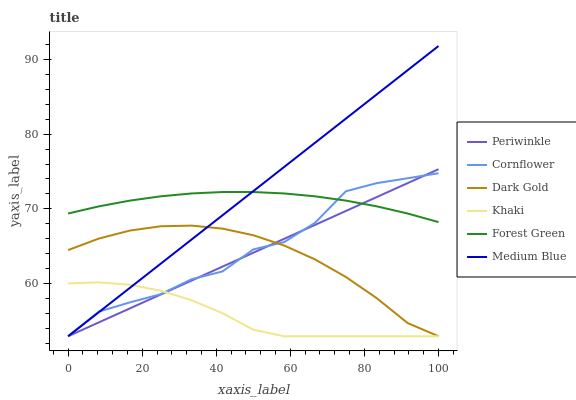Does Khaki have the minimum area under the curve?
Answer yes or no. Yes. Does Medium Blue have the maximum area under the curve?
Answer yes or no. Yes. Does Dark Gold have the minimum area under the curve?
Answer yes or no. No. Does Dark Gold have the maximum area under the curve?
Answer yes or no. No. Is Medium Blue the smoothest?
Answer yes or no. Yes. Is Cornflower the roughest?
Answer yes or no. Yes. Is Khaki the smoothest?
Answer yes or no. No. Is Khaki the roughest?
Answer yes or no. No. Does Forest Green have the lowest value?
Answer yes or no. No. Does Medium Blue have the highest value?
Answer yes or no. Yes. Does Dark Gold have the highest value?
Answer yes or no. No. Is Dark Gold less than Forest Green?
Answer yes or no. Yes. Is Forest Green greater than Dark Gold?
Answer yes or no. Yes. Does Cornflower intersect Periwinkle?
Answer yes or no. Yes. Is Cornflower less than Periwinkle?
Answer yes or no. No. Is Cornflower greater than Periwinkle?
Answer yes or no. No. Does Dark Gold intersect Forest Green?
Answer yes or no. No. 